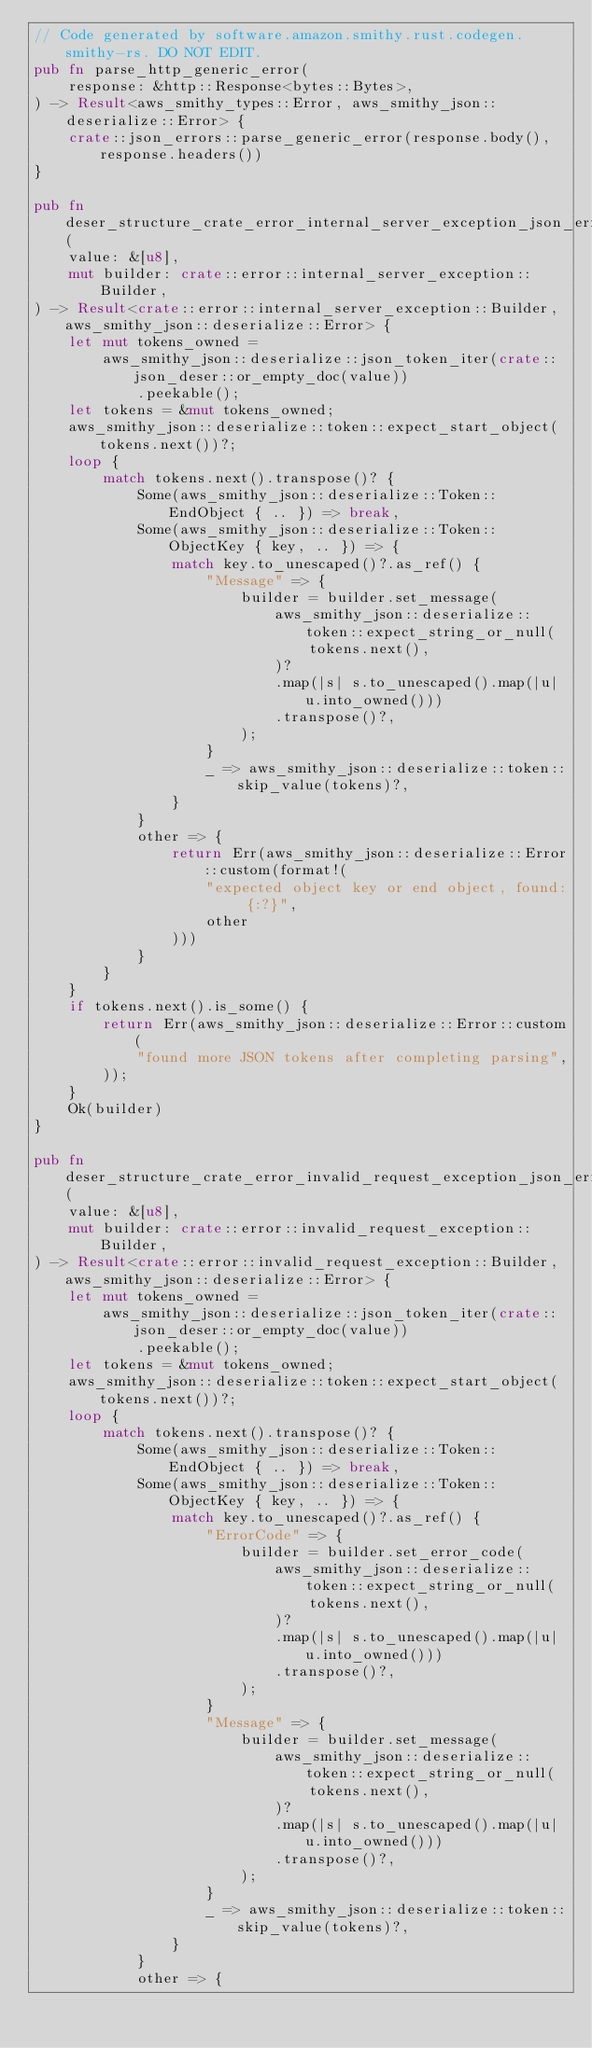<code> <loc_0><loc_0><loc_500><loc_500><_Rust_>// Code generated by software.amazon.smithy.rust.codegen.smithy-rs. DO NOT EDIT.
pub fn parse_http_generic_error(
    response: &http::Response<bytes::Bytes>,
) -> Result<aws_smithy_types::Error, aws_smithy_json::deserialize::Error> {
    crate::json_errors::parse_generic_error(response.body(), response.headers())
}

pub fn deser_structure_crate_error_internal_server_exception_json_err(
    value: &[u8],
    mut builder: crate::error::internal_server_exception::Builder,
) -> Result<crate::error::internal_server_exception::Builder, aws_smithy_json::deserialize::Error> {
    let mut tokens_owned =
        aws_smithy_json::deserialize::json_token_iter(crate::json_deser::or_empty_doc(value))
            .peekable();
    let tokens = &mut tokens_owned;
    aws_smithy_json::deserialize::token::expect_start_object(tokens.next())?;
    loop {
        match tokens.next().transpose()? {
            Some(aws_smithy_json::deserialize::Token::EndObject { .. }) => break,
            Some(aws_smithy_json::deserialize::Token::ObjectKey { key, .. }) => {
                match key.to_unescaped()?.as_ref() {
                    "Message" => {
                        builder = builder.set_message(
                            aws_smithy_json::deserialize::token::expect_string_or_null(
                                tokens.next(),
                            )?
                            .map(|s| s.to_unescaped().map(|u| u.into_owned()))
                            .transpose()?,
                        );
                    }
                    _ => aws_smithy_json::deserialize::token::skip_value(tokens)?,
                }
            }
            other => {
                return Err(aws_smithy_json::deserialize::Error::custom(format!(
                    "expected object key or end object, found: {:?}",
                    other
                )))
            }
        }
    }
    if tokens.next().is_some() {
        return Err(aws_smithy_json::deserialize::Error::custom(
            "found more JSON tokens after completing parsing",
        ));
    }
    Ok(builder)
}

pub fn deser_structure_crate_error_invalid_request_exception_json_err(
    value: &[u8],
    mut builder: crate::error::invalid_request_exception::Builder,
) -> Result<crate::error::invalid_request_exception::Builder, aws_smithy_json::deserialize::Error> {
    let mut tokens_owned =
        aws_smithy_json::deserialize::json_token_iter(crate::json_deser::or_empty_doc(value))
            .peekable();
    let tokens = &mut tokens_owned;
    aws_smithy_json::deserialize::token::expect_start_object(tokens.next())?;
    loop {
        match tokens.next().transpose()? {
            Some(aws_smithy_json::deserialize::Token::EndObject { .. }) => break,
            Some(aws_smithy_json::deserialize::Token::ObjectKey { key, .. }) => {
                match key.to_unescaped()?.as_ref() {
                    "ErrorCode" => {
                        builder = builder.set_error_code(
                            aws_smithy_json::deserialize::token::expect_string_or_null(
                                tokens.next(),
                            )?
                            .map(|s| s.to_unescaped().map(|u| u.into_owned()))
                            .transpose()?,
                        );
                    }
                    "Message" => {
                        builder = builder.set_message(
                            aws_smithy_json::deserialize::token::expect_string_or_null(
                                tokens.next(),
                            )?
                            .map(|s| s.to_unescaped().map(|u| u.into_owned()))
                            .transpose()?,
                        );
                    }
                    _ => aws_smithy_json::deserialize::token::skip_value(tokens)?,
                }
            }
            other => {</code> 